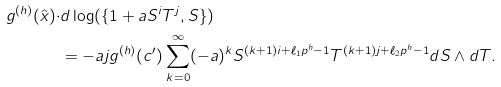<formula> <loc_0><loc_0><loc_500><loc_500>g ^ { ( h ) } ( \hat { x } ) \cdot & d \log ( \{ 1 + a S ^ { i } T ^ { j } , S \} ) \\ & = - a j g ^ { ( h ) } ( c ^ { \prime } ) \sum _ { k = 0 } ^ { \infty } ( - a ) ^ { k } S ^ { ( k + 1 ) i + \ell _ { 1 } p ^ { h } - 1 } T ^ { ( k + 1 ) j + \ell _ { 2 } p ^ { h } - 1 } d S \wedge d T .</formula> 